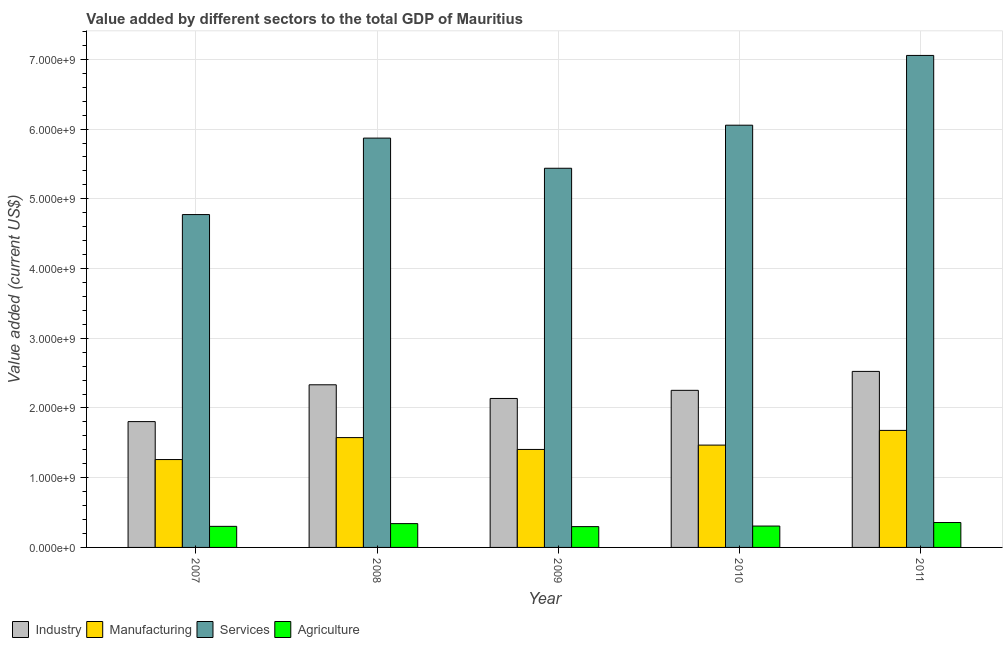How many different coloured bars are there?
Your answer should be very brief. 4. Are the number of bars per tick equal to the number of legend labels?
Offer a very short reply. Yes. Are the number of bars on each tick of the X-axis equal?
Ensure brevity in your answer.  Yes. How many bars are there on the 1st tick from the left?
Your answer should be compact. 4. What is the label of the 4th group of bars from the left?
Your response must be concise. 2010. What is the value added by agricultural sector in 2010?
Offer a terse response. 3.07e+08. Across all years, what is the maximum value added by agricultural sector?
Provide a succinct answer. 3.57e+08. Across all years, what is the minimum value added by agricultural sector?
Offer a very short reply. 2.98e+08. In which year was the value added by manufacturing sector minimum?
Offer a very short reply. 2007. What is the total value added by manufacturing sector in the graph?
Keep it short and to the point. 7.39e+09. What is the difference between the value added by manufacturing sector in 2007 and that in 2010?
Your answer should be compact. -2.07e+08. What is the difference between the value added by industrial sector in 2009 and the value added by services sector in 2007?
Your answer should be compact. 3.32e+08. What is the average value added by manufacturing sector per year?
Provide a succinct answer. 1.48e+09. What is the ratio of the value added by agricultural sector in 2008 to that in 2009?
Offer a very short reply. 1.14. Is the difference between the value added by agricultural sector in 2009 and 2011 greater than the difference between the value added by services sector in 2009 and 2011?
Your response must be concise. No. What is the difference between the highest and the second highest value added by agricultural sector?
Ensure brevity in your answer.  1.58e+07. What is the difference between the highest and the lowest value added by manufacturing sector?
Offer a very short reply. 4.18e+08. What does the 3rd bar from the left in 2010 represents?
Provide a short and direct response. Services. What does the 4th bar from the right in 2011 represents?
Offer a terse response. Industry. How many bars are there?
Offer a very short reply. 20. Are all the bars in the graph horizontal?
Make the answer very short. No. What is the difference between two consecutive major ticks on the Y-axis?
Your response must be concise. 1.00e+09. Does the graph contain grids?
Provide a short and direct response. Yes. Where does the legend appear in the graph?
Offer a very short reply. Bottom left. How many legend labels are there?
Give a very brief answer. 4. How are the legend labels stacked?
Provide a short and direct response. Horizontal. What is the title of the graph?
Provide a short and direct response. Value added by different sectors to the total GDP of Mauritius. What is the label or title of the X-axis?
Your response must be concise. Year. What is the label or title of the Y-axis?
Offer a terse response. Value added (current US$). What is the Value added (current US$) of Industry in 2007?
Ensure brevity in your answer.  1.80e+09. What is the Value added (current US$) in Manufacturing in 2007?
Keep it short and to the point. 1.26e+09. What is the Value added (current US$) of Services in 2007?
Ensure brevity in your answer.  4.77e+09. What is the Value added (current US$) in Agriculture in 2007?
Make the answer very short. 3.02e+08. What is the Value added (current US$) of Industry in 2008?
Ensure brevity in your answer.  2.33e+09. What is the Value added (current US$) in Manufacturing in 2008?
Provide a short and direct response. 1.58e+09. What is the Value added (current US$) in Services in 2008?
Give a very brief answer. 5.87e+09. What is the Value added (current US$) in Agriculture in 2008?
Ensure brevity in your answer.  3.41e+08. What is the Value added (current US$) of Industry in 2009?
Provide a succinct answer. 2.14e+09. What is the Value added (current US$) of Manufacturing in 2009?
Offer a very short reply. 1.41e+09. What is the Value added (current US$) of Services in 2009?
Keep it short and to the point. 5.44e+09. What is the Value added (current US$) in Agriculture in 2009?
Offer a very short reply. 2.98e+08. What is the Value added (current US$) in Industry in 2010?
Provide a short and direct response. 2.25e+09. What is the Value added (current US$) of Manufacturing in 2010?
Your answer should be very brief. 1.47e+09. What is the Value added (current US$) of Services in 2010?
Your answer should be very brief. 6.06e+09. What is the Value added (current US$) of Agriculture in 2010?
Offer a very short reply. 3.07e+08. What is the Value added (current US$) in Industry in 2011?
Give a very brief answer. 2.52e+09. What is the Value added (current US$) of Manufacturing in 2011?
Make the answer very short. 1.68e+09. What is the Value added (current US$) of Services in 2011?
Give a very brief answer. 7.06e+09. What is the Value added (current US$) of Agriculture in 2011?
Ensure brevity in your answer.  3.57e+08. Across all years, what is the maximum Value added (current US$) in Industry?
Your response must be concise. 2.52e+09. Across all years, what is the maximum Value added (current US$) in Manufacturing?
Give a very brief answer. 1.68e+09. Across all years, what is the maximum Value added (current US$) in Services?
Make the answer very short. 7.06e+09. Across all years, what is the maximum Value added (current US$) of Agriculture?
Provide a succinct answer. 3.57e+08. Across all years, what is the minimum Value added (current US$) in Industry?
Provide a short and direct response. 1.80e+09. Across all years, what is the minimum Value added (current US$) in Manufacturing?
Ensure brevity in your answer.  1.26e+09. Across all years, what is the minimum Value added (current US$) of Services?
Give a very brief answer. 4.77e+09. Across all years, what is the minimum Value added (current US$) of Agriculture?
Your answer should be very brief. 2.98e+08. What is the total Value added (current US$) in Industry in the graph?
Provide a succinct answer. 1.11e+1. What is the total Value added (current US$) of Manufacturing in the graph?
Keep it short and to the point. 7.39e+09. What is the total Value added (current US$) in Services in the graph?
Provide a short and direct response. 2.92e+1. What is the total Value added (current US$) of Agriculture in the graph?
Your answer should be compact. 1.61e+09. What is the difference between the Value added (current US$) in Industry in 2007 and that in 2008?
Your response must be concise. -5.28e+08. What is the difference between the Value added (current US$) in Manufacturing in 2007 and that in 2008?
Your response must be concise. -3.15e+08. What is the difference between the Value added (current US$) in Services in 2007 and that in 2008?
Ensure brevity in your answer.  -1.10e+09. What is the difference between the Value added (current US$) of Agriculture in 2007 and that in 2008?
Give a very brief answer. -3.92e+07. What is the difference between the Value added (current US$) in Industry in 2007 and that in 2009?
Your answer should be compact. -3.32e+08. What is the difference between the Value added (current US$) of Manufacturing in 2007 and that in 2009?
Provide a succinct answer. -1.45e+08. What is the difference between the Value added (current US$) in Services in 2007 and that in 2009?
Your response must be concise. -6.64e+08. What is the difference between the Value added (current US$) of Agriculture in 2007 and that in 2009?
Keep it short and to the point. 3.76e+06. What is the difference between the Value added (current US$) of Industry in 2007 and that in 2010?
Provide a succinct answer. -4.49e+08. What is the difference between the Value added (current US$) of Manufacturing in 2007 and that in 2010?
Keep it short and to the point. -2.07e+08. What is the difference between the Value added (current US$) in Services in 2007 and that in 2010?
Your answer should be compact. -1.28e+09. What is the difference between the Value added (current US$) in Agriculture in 2007 and that in 2010?
Provide a succinct answer. -4.35e+06. What is the difference between the Value added (current US$) of Industry in 2007 and that in 2011?
Offer a very short reply. -7.20e+08. What is the difference between the Value added (current US$) in Manufacturing in 2007 and that in 2011?
Give a very brief answer. -4.18e+08. What is the difference between the Value added (current US$) of Services in 2007 and that in 2011?
Your answer should be compact. -2.28e+09. What is the difference between the Value added (current US$) in Agriculture in 2007 and that in 2011?
Your answer should be very brief. -5.49e+07. What is the difference between the Value added (current US$) of Industry in 2008 and that in 2009?
Provide a succinct answer. 1.96e+08. What is the difference between the Value added (current US$) in Manufacturing in 2008 and that in 2009?
Provide a succinct answer. 1.70e+08. What is the difference between the Value added (current US$) of Services in 2008 and that in 2009?
Keep it short and to the point. 4.33e+08. What is the difference between the Value added (current US$) in Agriculture in 2008 and that in 2009?
Offer a terse response. 4.29e+07. What is the difference between the Value added (current US$) in Industry in 2008 and that in 2010?
Give a very brief answer. 7.95e+07. What is the difference between the Value added (current US$) in Manufacturing in 2008 and that in 2010?
Your answer should be compact. 1.08e+08. What is the difference between the Value added (current US$) of Services in 2008 and that in 2010?
Your response must be concise. -1.85e+08. What is the difference between the Value added (current US$) of Agriculture in 2008 and that in 2010?
Make the answer very short. 3.48e+07. What is the difference between the Value added (current US$) of Industry in 2008 and that in 2011?
Provide a succinct answer. -1.92e+08. What is the difference between the Value added (current US$) in Manufacturing in 2008 and that in 2011?
Provide a succinct answer. -1.03e+08. What is the difference between the Value added (current US$) of Services in 2008 and that in 2011?
Make the answer very short. -1.19e+09. What is the difference between the Value added (current US$) of Agriculture in 2008 and that in 2011?
Give a very brief answer. -1.58e+07. What is the difference between the Value added (current US$) of Industry in 2009 and that in 2010?
Ensure brevity in your answer.  -1.17e+08. What is the difference between the Value added (current US$) of Manufacturing in 2009 and that in 2010?
Ensure brevity in your answer.  -6.25e+07. What is the difference between the Value added (current US$) of Services in 2009 and that in 2010?
Your response must be concise. -6.18e+08. What is the difference between the Value added (current US$) in Agriculture in 2009 and that in 2010?
Provide a succinct answer. -8.12e+06. What is the difference between the Value added (current US$) in Industry in 2009 and that in 2011?
Offer a very short reply. -3.88e+08. What is the difference between the Value added (current US$) of Manufacturing in 2009 and that in 2011?
Your response must be concise. -2.73e+08. What is the difference between the Value added (current US$) in Services in 2009 and that in 2011?
Provide a short and direct response. -1.62e+09. What is the difference between the Value added (current US$) of Agriculture in 2009 and that in 2011?
Give a very brief answer. -5.87e+07. What is the difference between the Value added (current US$) of Industry in 2010 and that in 2011?
Provide a short and direct response. -2.72e+08. What is the difference between the Value added (current US$) of Manufacturing in 2010 and that in 2011?
Give a very brief answer. -2.11e+08. What is the difference between the Value added (current US$) in Services in 2010 and that in 2011?
Ensure brevity in your answer.  -1.00e+09. What is the difference between the Value added (current US$) in Agriculture in 2010 and that in 2011?
Provide a succinct answer. -5.06e+07. What is the difference between the Value added (current US$) of Industry in 2007 and the Value added (current US$) of Manufacturing in 2008?
Ensure brevity in your answer.  2.29e+08. What is the difference between the Value added (current US$) of Industry in 2007 and the Value added (current US$) of Services in 2008?
Offer a terse response. -4.07e+09. What is the difference between the Value added (current US$) of Industry in 2007 and the Value added (current US$) of Agriculture in 2008?
Provide a short and direct response. 1.46e+09. What is the difference between the Value added (current US$) of Manufacturing in 2007 and the Value added (current US$) of Services in 2008?
Keep it short and to the point. -4.61e+09. What is the difference between the Value added (current US$) in Manufacturing in 2007 and the Value added (current US$) in Agriculture in 2008?
Keep it short and to the point. 9.19e+08. What is the difference between the Value added (current US$) of Services in 2007 and the Value added (current US$) of Agriculture in 2008?
Offer a terse response. 4.43e+09. What is the difference between the Value added (current US$) in Industry in 2007 and the Value added (current US$) in Manufacturing in 2009?
Offer a very short reply. 3.99e+08. What is the difference between the Value added (current US$) in Industry in 2007 and the Value added (current US$) in Services in 2009?
Offer a very short reply. -3.63e+09. What is the difference between the Value added (current US$) of Industry in 2007 and the Value added (current US$) of Agriculture in 2009?
Offer a very short reply. 1.51e+09. What is the difference between the Value added (current US$) of Manufacturing in 2007 and the Value added (current US$) of Services in 2009?
Offer a very short reply. -4.18e+09. What is the difference between the Value added (current US$) of Manufacturing in 2007 and the Value added (current US$) of Agriculture in 2009?
Provide a succinct answer. 9.62e+08. What is the difference between the Value added (current US$) of Services in 2007 and the Value added (current US$) of Agriculture in 2009?
Your answer should be compact. 4.48e+09. What is the difference between the Value added (current US$) in Industry in 2007 and the Value added (current US$) in Manufacturing in 2010?
Your answer should be very brief. 3.37e+08. What is the difference between the Value added (current US$) of Industry in 2007 and the Value added (current US$) of Services in 2010?
Your response must be concise. -4.25e+09. What is the difference between the Value added (current US$) of Industry in 2007 and the Value added (current US$) of Agriculture in 2010?
Your answer should be very brief. 1.50e+09. What is the difference between the Value added (current US$) of Manufacturing in 2007 and the Value added (current US$) of Services in 2010?
Offer a very short reply. -4.80e+09. What is the difference between the Value added (current US$) of Manufacturing in 2007 and the Value added (current US$) of Agriculture in 2010?
Your answer should be compact. 9.54e+08. What is the difference between the Value added (current US$) of Services in 2007 and the Value added (current US$) of Agriculture in 2010?
Your response must be concise. 4.47e+09. What is the difference between the Value added (current US$) of Industry in 2007 and the Value added (current US$) of Manufacturing in 2011?
Your response must be concise. 1.26e+08. What is the difference between the Value added (current US$) in Industry in 2007 and the Value added (current US$) in Services in 2011?
Give a very brief answer. -5.25e+09. What is the difference between the Value added (current US$) of Industry in 2007 and the Value added (current US$) of Agriculture in 2011?
Your response must be concise. 1.45e+09. What is the difference between the Value added (current US$) of Manufacturing in 2007 and the Value added (current US$) of Services in 2011?
Make the answer very short. -5.80e+09. What is the difference between the Value added (current US$) in Manufacturing in 2007 and the Value added (current US$) in Agriculture in 2011?
Ensure brevity in your answer.  9.03e+08. What is the difference between the Value added (current US$) in Services in 2007 and the Value added (current US$) in Agriculture in 2011?
Your answer should be compact. 4.42e+09. What is the difference between the Value added (current US$) in Industry in 2008 and the Value added (current US$) in Manufacturing in 2009?
Your answer should be very brief. 9.27e+08. What is the difference between the Value added (current US$) in Industry in 2008 and the Value added (current US$) in Services in 2009?
Your response must be concise. -3.11e+09. What is the difference between the Value added (current US$) of Industry in 2008 and the Value added (current US$) of Agriculture in 2009?
Give a very brief answer. 2.03e+09. What is the difference between the Value added (current US$) of Manufacturing in 2008 and the Value added (current US$) of Services in 2009?
Offer a very short reply. -3.86e+09. What is the difference between the Value added (current US$) in Manufacturing in 2008 and the Value added (current US$) in Agriculture in 2009?
Your answer should be compact. 1.28e+09. What is the difference between the Value added (current US$) of Services in 2008 and the Value added (current US$) of Agriculture in 2009?
Give a very brief answer. 5.57e+09. What is the difference between the Value added (current US$) of Industry in 2008 and the Value added (current US$) of Manufacturing in 2010?
Provide a succinct answer. 8.65e+08. What is the difference between the Value added (current US$) in Industry in 2008 and the Value added (current US$) in Services in 2010?
Give a very brief answer. -3.72e+09. What is the difference between the Value added (current US$) in Industry in 2008 and the Value added (current US$) in Agriculture in 2010?
Your answer should be very brief. 2.03e+09. What is the difference between the Value added (current US$) of Manufacturing in 2008 and the Value added (current US$) of Services in 2010?
Your response must be concise. -4.48e+09. What is the difference between the Value added (current US$) in Manufacturing in 2008 and the Value added (current US$) in Agriculture in 2010?
Your answer should be very brief. 1.27e+09. What is the difference between the Value added (current US$) in Services in 2008 and the Value added (current US$) in Agriculture in 2010?
Your answer should be very brief. 5.56e+09. What is the difference between the Value added (current US$) in Industry in 2008 and the Value added (current US$) in Manufacturing in 2011?
Keep it short and to the point. 6.54e+08. What is the difference between the Value added (current US$) in Industry in 2008 and the Value added (current US$) in Services in 2011?
Keep it short and to the point. -4.72e+09. What is the difference between the Value added (current US$) in Industry in 2008 and the Value added (current US$) in Agriculture in 2011?
Your answer should be compact. 1.98e+09. What is the difference between the Value added (current US$) in Manufacturing in 2008 and the Value added (current US$) in Services in 2011?
Your answer should be very brief. -5.48e+09. What is the difference between the Value added (current US$) in Manufacturing in 2008 and the Value added (current US$) in Agriculture in 2011?
Provide a succinct answer. 1.22e+09. What is the difference between the Value added (current US$) of Services in 2008 and the Value added (current US$) of Agriculture in 2011?
Keep it short and to the point. 5.51e+09. What is the difference between the Value added (current US$) in Industry in 2009 and the Value added (current US$) in Manufacturing in 2010?
Your answer should be very brief. 6.69e+08. What is the difference between the Value added (current US$) in Industry in 2009 and the Value added (current US$) in Services in 2010?
Offer a very short reply. -3.92e+09. What is the difference between the Value added (current US$) of Industry in 2009 and the Value added (current US$) of Agriculture in 2010?
Keep it short and to the point. 1.83e+09. What is the difference between the Value added (current US$) in Manufacturing in 2009 and the Value added (current US$) in Services in 2010?
Keep it short and to the point. -4.65e+09. What is the difference between the Value added (current US$) of Manufacturing in 2009 and the Value added (current US$) of Agriculture in 2010?
Keep it short and to the point. 1.10e+09. What is the difference between the Value added (current US$) in Services in 2009 and the Value added (current US$) in Agriculture in 2010?
Provide a short and direct response. 5.13e+09. What is the difference between the Value added (current US$) in Industry in 2009 and the Value added (current US$) in Manufacturing in 2011?
Ensure brevity in your answer.  4.58e+08. What is the difference between the Value added (current US$) of Industry in 2009 and the Value added (current US$) of Services in 2011?
Ensure brevity in your answer.  -4.92e+09. What is the difference between the Value added (current US$) in Industry in 2009 and the Value added (current US$) in Agriculture in 2011?
Give a very brief answer. 1.78e+09. What is the difference between the Value added (current US$) in Manufacturing in 2009 and the Value added (current US$) in Services in 2011?
Make the answer very short. -5.65e+09. What is the difference between the Value added (current US$) in Manufacturing in 2009 and the Value added (current US$) in Agriculture in 2011?
Your answer should be compact. 1.05e+09. What is the difference between the Value added (current US$) of Services in 2009 and the Value added (current US$) of Agriculture in 2011?
Your answer should be compact. 5.08e+09. What is the difference between the Value added (current US$) of Industry in 2010 and the Value added (current US$) of Manufacturing in 2011?
Your response must be concise. 5.75e+08. What is the difference between the Value added (current US$) in Industry in 2010 and the Value added (current US$) in Services in 2011?
Give a very brief answer. -4.80e+09. What is the difference between the Value added (current US$) in Industry in 2010 and the Value added (current US$) in Agriculture in 2011?
Offer a very short reply. 1.90e+09. What is the difference between the Value added (current US$) of Manufacturing in 2010 and the Value added (current US$) of Services in 2011?
Provide a short and direct response. -5.59e+09. What is the difference between the Value added (current US$) of Manufacturing in 2010 and the Value added (current US$) of Agriculture in 2011?
Your answer should be very brief. 1.11e+09. What is the difference between the Value added (current US$) in Services in 2010 and the Value added (current US$) in Agriculture in 2011?
Provide a succinct answer. 5.70e+09. What is the average Value added (current US$) of Industry per year?
Your answer should be compact. 2.21e+09. What is the average Value added (current US$) in Manufacturing per year?
Give a very brief answer. 1.48e+09. What is the average Value added (current US$) of Services per year?
Your response must be concise. 5.84e+09. What is the average Value added (current US$) in Agriculture per year?
Make the answer very short. 3.21e+08. In the year 2007, what is the difference between the Value added (current US$) in Industry and Value added (current US$) in Manufacturing?
Offer a terse response. 5.44e+08. In the year 2007, what is the difference between the Value added (current US$) in Industry and Value added (current US$) in Services?
Your answer should be very brief. -2.97e+09. In the year 2007, what is the difference between the Value added (current US$) of Industry and Value added (current US$) of Agriculture?
Keep it short and to the point. 1.50e+09. In the year 2007, what is the difference between the Value added (current US$) in Manufacturing and Value added (current US$) in Services?
Your response must be concise. -3.51e+09. In the year 2007, what is the difference between the Value added (current US$) in Manufacturing and Value added (current US$) in Agriculture?
Your answer should be compact. 9.58e+08. In the year 2007, what is the difference between the Value added (current US$) in Services and Value added (current US$) in Agriculture?
Provide a succinct answer. 4.47e+09. In the year 2008, what is the difference between the Value added (current US$) of Industry and Value added (current US$) of Manufacturing?
Ensure brevity in your answer.  7.57e+08. In the year 2008, what is the difference between the Value added (current US$) in Industry and Value added (current US$) in Services?
Give a very brief answer. -3.54e+09. In the year 2008, what is the difference between the Value added (current US$) in Industry and Value added (current US$) in Agriculture?
Provide a succinct answer. 1.99e+09. In the year 2008, what is the difference between the Value added (current US$) of Manufacturing and Value added (current US$) of Services?
Provide a short and direct response. -4.30e+09. In the year 2008, what is the difference between the Value added (current US$) of Manufacturing and Value added (current US$) of Agriculture?
Provide a succinct answer. 1.23e+09. In the year 2008, what is the difference between the Value added (current US$) in Services and Value added (current US$) in Agriculture?
Offer a terse response. 5.53e+09. In the year 2009, what is the difference between the Value added (current US$) in Industry and Value added (current US$) in Manufacturing?
Provide a short and direct response. 7.31e+08. In the year 2009, what is the difference between the Value added (current US$) in Industry and Value added (current US$) in Services?
Give a very brief answer. -3.30e+09. In the year 2009, what is the difference between the Value added (current US$) of Industry and Value added (current US$) of Agriculture?
Keep it short and to the point. 1.84e+09. In the year 2009, what is the difference between the Value added (current US$) in Manufacturing and Value added (current US$) in Services?
Your answer should be compact. -4.03e+09. In the year 2009, what is the difference between the Value added (current US$) of Manufacturing and Value added (current US$) of Agriculture?
Make the answer very short. 1.11e+09. In the year 2009, what is the difference between the Value added (current US$) in Services and Value added (current US$) in Agriculture?
Your answer should be very brief. 5.14e+09. In the year 2010, what is the difference between the Value added (current US$) of Industry and Value added (current US$) of Manufacturing?
Provide a succinct answer. 7.85e+08. In the year 2010, what is the difference between the Value added (current US$) in Industry and Value added (current US$) in Services?
Make the answer very short. -3.80e+09. In the year 2010, what is the difference between the Value added (current US$) in Industry and Value added (current US$) in Agriculture?
Give a very brief answer. 1.95e+09. In the year 2010, what is the difference between the Value added (current US$) of Manufacturing and Value added (current US$) of Services?
Offer a terse response. -4.59e+09. In the year 2010, what is the difference between the Value added (current US$) of Manufacturing and Value added (current US$) of Agriculture?
Offer a very short reply. 1.16e+09. In the year 2010, what is the difference between the Value added (current US$) in Services and Value added (current US$) in Agriculture?
Ensure brevity in your answer.  5.75e+09. In the year 2011, what is the difference between the Value added (current US$) of Industry and Value added (current US$) of Manufacturing?
Make the answer very short. 8.46e+08. In the year 2011, what is the difference between the Value added (current US$) of Industry and Value added (current US$) of Services?
Your response must be concise. -4.53e+09. In the year 2011, what is the difference between the Value added (current US$) of Industry and Value added (current US$) of Agriculture?
Your response must be concise. 2.17e+09. In the year 2011, what is the difference between the Value added (current US$) in Manufacturing and Value added (current US$) in Services?
Provide a short and direct response. -5.38e+09. In the year 2011, what is the difference between the Value added (current US$) in Manufacturing and Value added (current US$) in Agriculture?
Your answer should be very brief. 1.32e+09. In the year 2011, what is the difference between the Value added (current US$) in Services and Value added (current US$) in Agriculture?
Make the answer very short. 6.70e+09. What is the ratio of the Value added (current US$) in Industry in 2007 to that in 2008?
Provide a short and direct response. 0.77. What is the ratio of the Value added (current US$) in Manufacturing in 2007 to that in 2008?
Give a very brief answer. 0.8. What is the ratio of the Value added (current US$) in Services in 2007 to that in 2008?
Your answer should be very brief. 0.81. What is the ratio of the Value added (current US$) in Agriculture in 2007 to that in 2008?
Offer a very short reply. 0.89. What is the ratio of the Value added (current US$) in Industry in 2007 to that in 2009?
Your answer should be compact. 0.84. What is the ratio of the Value added (current US$) of Manufacturing in 2007 to that in 2009?
Ensure brevity in your answer.  0.9. What is the ratio of the Value added (current US$) of Services in 2007 to that in 2009?
Give a very brief answer. 0.88. What is the ratio of the Value added (current US$) in Agriculture in 2007 to that in 2009?
Keep it short and to the point. 1.01. What is the ratio of the Value added (current US$) in Industry in 2007 to that in 2010?
Offer a terse response. 0.8. What is the ratio of the Value added (current US$) in Manufacturing in 2007 to that in 2010?
Your answer should be very brief. 0.86. What is the ratio of the Value added (current US$) in Services in 2007 to that in 2010?
Offer a terse response. 0.79. What is the ratio of the Value added (current US$) of Agriculture in 2007 to that in 2010?
Your response must be concise. 0.99. What is the ratio of the Value added (current US$) of Industry in 2007 to that in 2011?
Your answer should be very brief. 0.71. What is the ratio of the Value added (current US$) in Manufacturing in 2007 to that in 2011?
Make the answer very short. 0.75. What is the ratio of the Value added (current US$) of Services in 2007 to that in 2011?
Provide a short and direct response. 0.68. What is the ratio of the Value added (current US$) in Agriculture in 2007 to that in 2011?
Provide a short and direct response. 0.85. What is the ratio of the Value added (current US$) in Industry in 2008 to that in 2009?
Make the answer very short. 1.09. What is the ratio of the Value added (current US$) in Manufacturing in 2008 to that in 2009?
Give a very brief answer. 1.12. What is the ratio of the Value added (current US$) in Services in 2008 to that in 2009?
Offer a very short reply. 1.08. What is the ratio of the Value added (current US$) of Agriculture in 2008 to that in 2009?
Keep it short and to the point. 1.14. What is the ratio of the Value added (current US$) in Industry in 2008 to that in 2010?
Keep it short and to the point. 1.04. What is the ratio of the Value added (current US$) of Manufacturing in 2008 to that in 2010?
Offer a terse response. 1.07. What is the ratio of the Value added (current US$) of Services in 2008 to that in 2010?
Your response must be concise. 0.97. What is the ratio of the Value added (current US$) in Agriculture in 2008 to that in 2010?
Your answer should be compact. 1.11. What is the ratio of the Value added (current US$) in Industry in 2008 to that in 2011?
Provide a short and direct response. 0.92. What is the ratio of the Value added (current US$) in Manufacturing in 2008 to that in 2011?
Offer a terse response. 0.94. What is the ratio of the Value added (current US$) in Services in 2008 to that in 2011?
Make the answer very short. 0.83. What is the ratio of the Value added (current US$) of Agriculture in 2008 to that in 2011?
Keep it short and to the point. 0.96. What is the ratio of the Value added (current US$) of Industry in 2009 to that in 2010?
Make the answer very short. 0.95. What is the ratio of the Value added (current US$) of Manufacturing in 2009 to that in 2010?
Keep it short and to the point. 0.96. What is the ratio of the Value added (current US$) in Services in 2009 to that in 2010?
Your response must be concise. 0.9. What is the ratio of the Value added (current US$) of Agriculture in 2009 to that in 2010?
Provide a short and direct response. 0.97. What is the ratio of the Value added (current US$) of Industry in 2009 to that in 2011?
Your response must be concise. 0.85. What is the ratio of the Value added (current US$) of Manufacturing in 2009 to that in 2011?
Provide a succinct answer. 0.84. What is the ratio of the Value added (current US$) of Services in 2009 to that in 2011?
Provide a succinct answer. 0.77. What is the ratio of the Value added (current US$) in Agriculture in 2009 to that in 2011?
Your answer should be very brief. 0.84. What is the ratio of the Value added (current US$) in Industry in 2010 to that in 2011?
Your response must be concise. 0.89. What is the ratio of the Value added (current US$) in Manufacturing in 2010 to that in 2011?
Offer a very short reply. 0.87. What is the ratio of the Value added (current US$) in Services in 2010 to that in 2011?
Ensure brevity in your answer.  0.86. What is the ratio of the Value added (current US$) in Agriculture in 2010 to that in 2011?
Make the answer very short. 0.86. What is the difference between the highest and the second highest Value added (current US$) in Industry?
Make the answer very short. 1.92e+08. What is the difference between the highest and the second highest Value added (current US$) of Manufacturing?
Your answer should be very brief. 1.03e+08. What is the difference between the highest and the second highest Value added (current US$) of Services?
Keep it short and to the point. 1.00e+09. What is the difference between the highest and the second highest Value added (current US$) in Agriculture?
Keep it short and to the point. 1.58e+07. What is the difference between the highest and the lowest Value added (current US$) of Industry?
Keep it short and to the point. 7.20e+08. What is the difference between the highest and the lowest Value added (current US$) of Manufacturing?
Your response must be concise. 4.18e+08. What is the difference between the highest and the lowest Value added (current US$) of Services?
Offer a very short reply. 2.28e+09. What is the difference between the highest and the lowest Value added (current US$) in Agriculture?
Make the answer very short. 5.87e+07. 